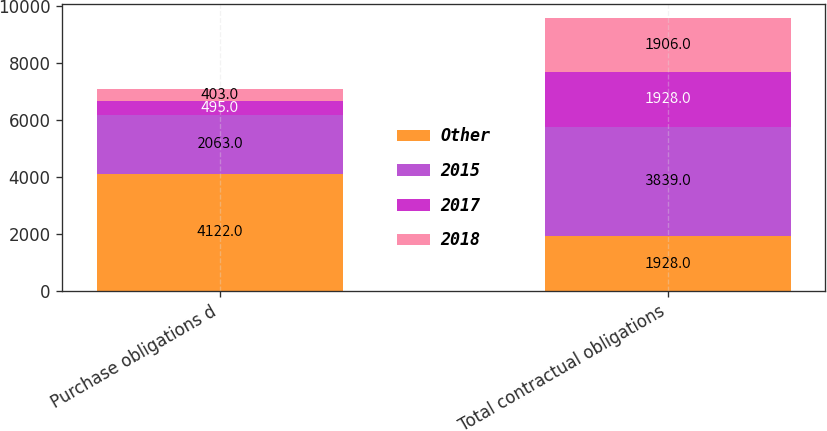Convert chart. <chart><loc_0><loc_0><loc_500><loc_500><stacked_bar_chart><ecel><fcel>Purchase obligations d<fcel>Total contractual obligations<nl><fcel>Other<fcel>4122<fcel>1928<nl><fcel>2015<fcel>2063<fcel>3839<nl><fcel>2017<fcel>495<fcel>1928<nl><fcel>2018<fcel>403<fcel>1906<nl></chart> 